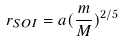Convert formula to latex. <formula><loc_0><loc_0><loc_500><loc_500>r _ { S O I } = a ( \frac { m } { M } ) ^ { 2 / 5 }</formula> 